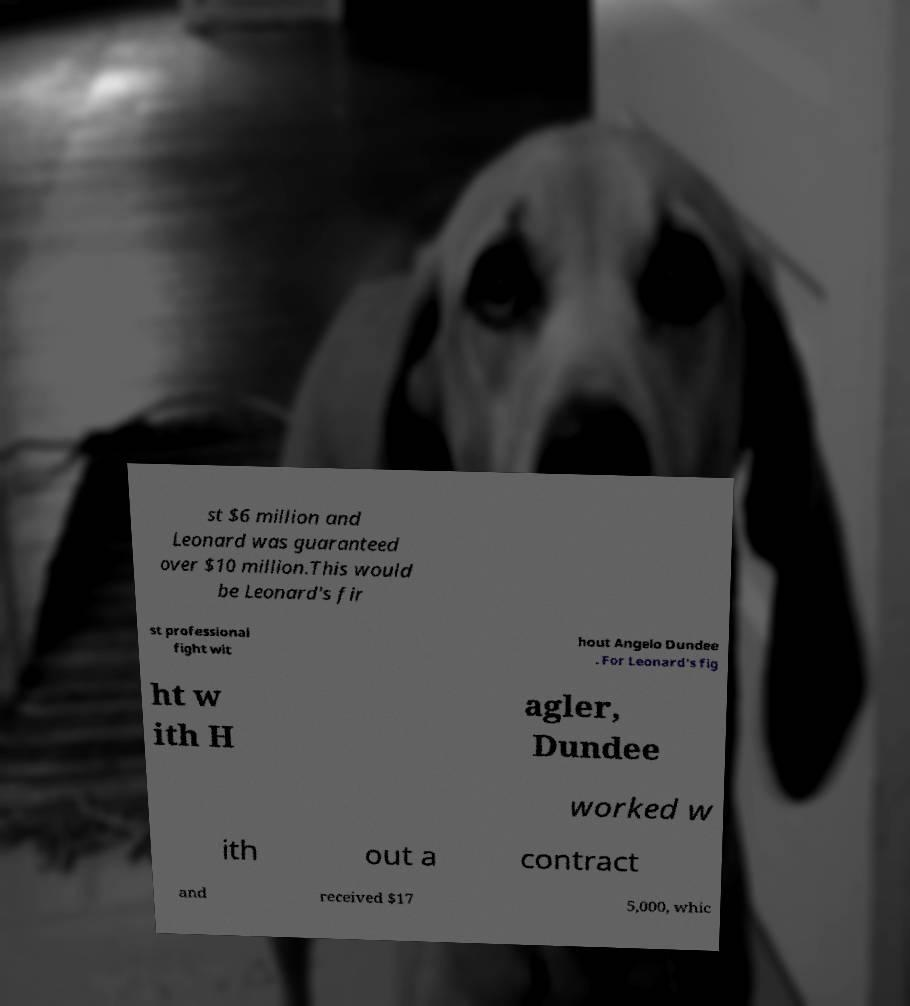Can you read and provide the text displayed in the image?This photo seems to have some interesting text. Can you extract and type it out for me? st $6 million and Leonard was guaranteed over $10 million.This would be Leonard's fir st professional fight wit hout Angelo Dundee . For Leonard's fig ht w ith H agler, Dundee worked w ith out a contract and received $17 5,000, whic 